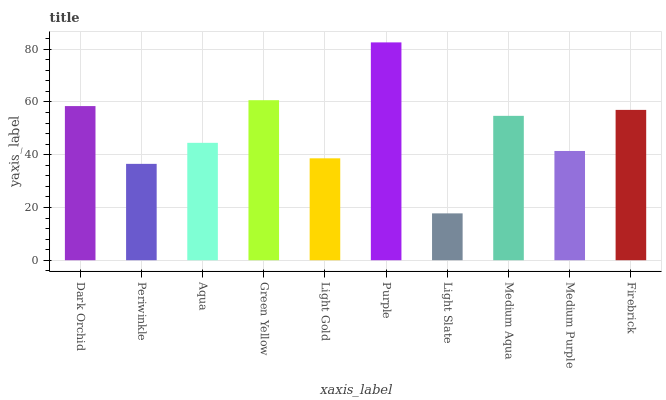Is Light Slate the minimum?
Answer yes or no. Yes. Is Purple the maximum?
Answer yes or no. Yes. Is Periwinkle the minimum?
Answer yes or no. No. Is Periwinkle the maximum?
Answer yes or no. No. Is Dark Orchid greater than Periwinkle?
Answer yes or no. Yes. Is Periwinkle less than Dark Orchid?
Answer yes or no. Yes. Is Periwinkle greater than Dark Orchid?
Answer yes or no. No. Is Dark Orchid less than Periwinkle?
Answer yes or no. No. Is Medium Aqua the high median?
Answer yes or no. Yes. Is Aqua the low median?
Answer yes or no. Yes. Is Periwinkle the high median?
Answer yes or no. No. Is Purple the low median?
Answer yes or no. No. 